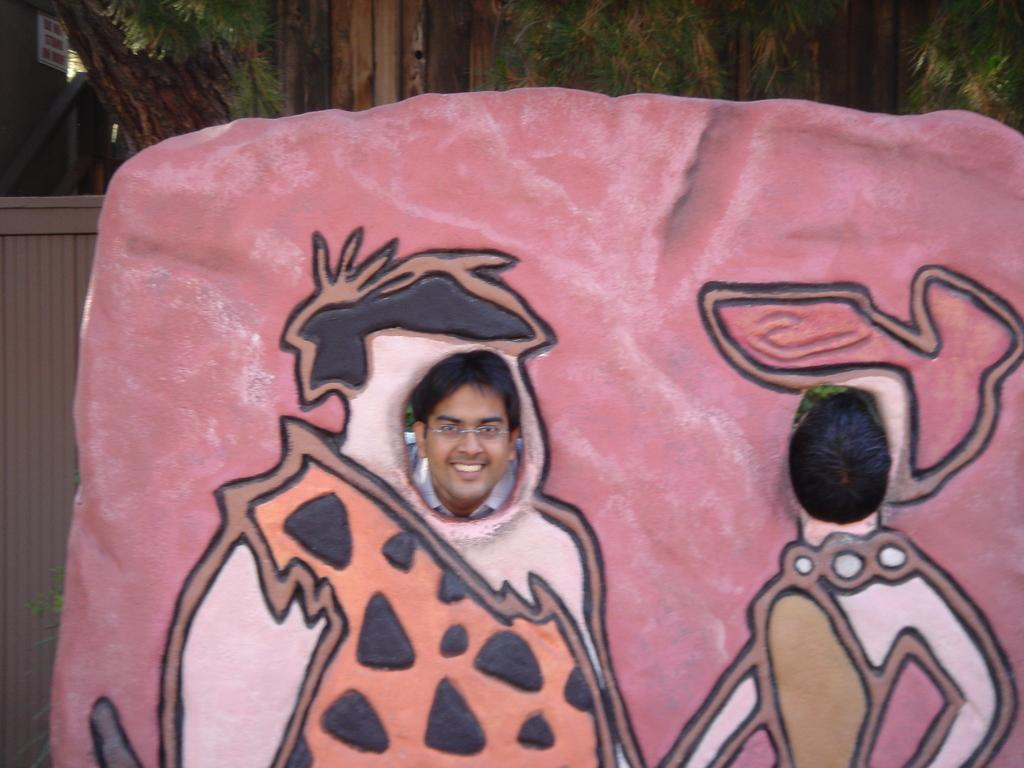What part of a person is visible in the image? There is a person's head and face visible in the image. How is the person's head and face being viewed in the image? The head and face are seen through a wall. What can be seen in the background of the image? There are trees and a door in the background of the image. What type of attention is the carpenter receiving from the person in the image? There is no carpenter present in the image, and therefore no interaction with a carpenter can be observed. What is the condition of the roof in the image? There is no roof visible in the image, so its condition cannot be determined. 